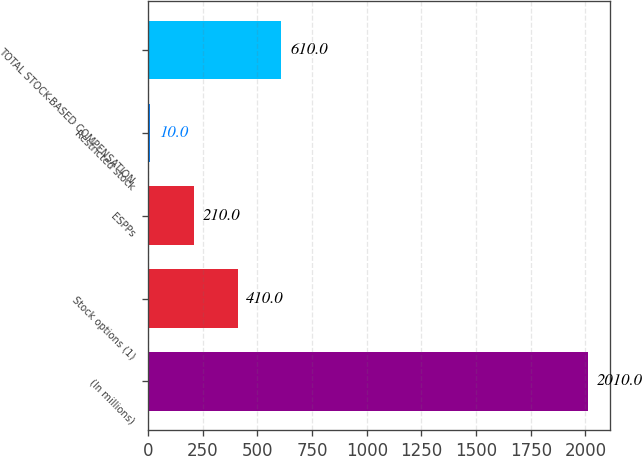<chart> <loc_0><loc_0><loc_500><loc_500><bar_chart><fcel>(In millions)<fcel>Stock options (1)<fcel>ESPPs<fcel>Restricted stock<fcel>TOTAL STOCK-BASED COMPENSATION<nl><fcel>2010<fcel>410<fcel>210<fcel>10<fcel>610<nl></chart> 